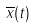Convert formula to latex. <formula><loc_0><loc_0><loc_500><loc_500>\overline { x } ( t )</formula> 